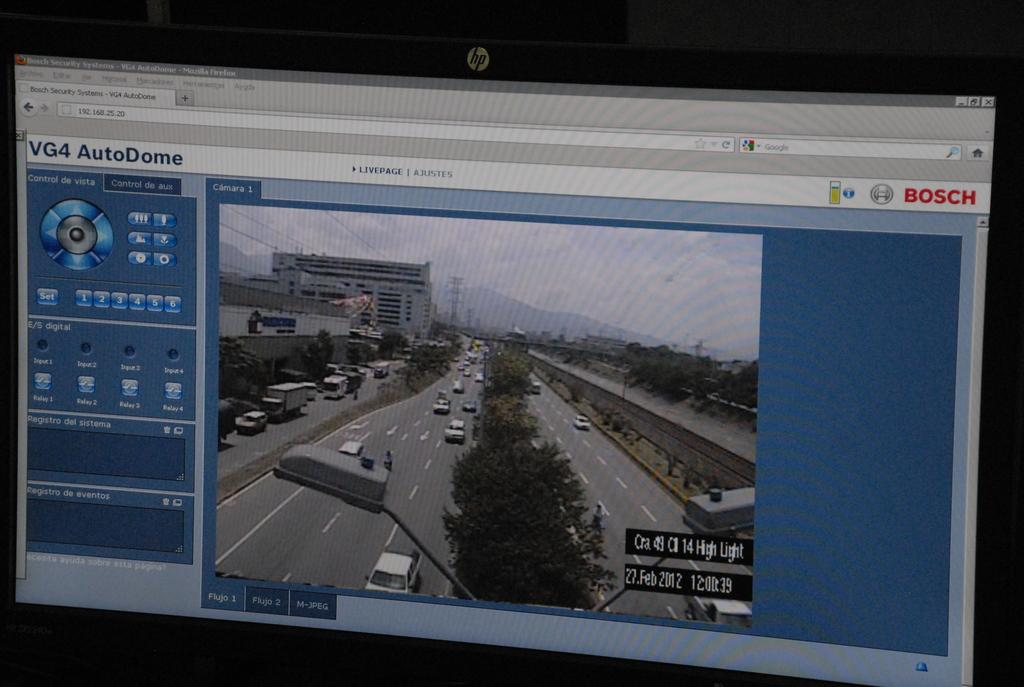<image>
Give a short and clear explanation of the subsequent image. A computer screen with cars on it called VG4 AutoDome. 